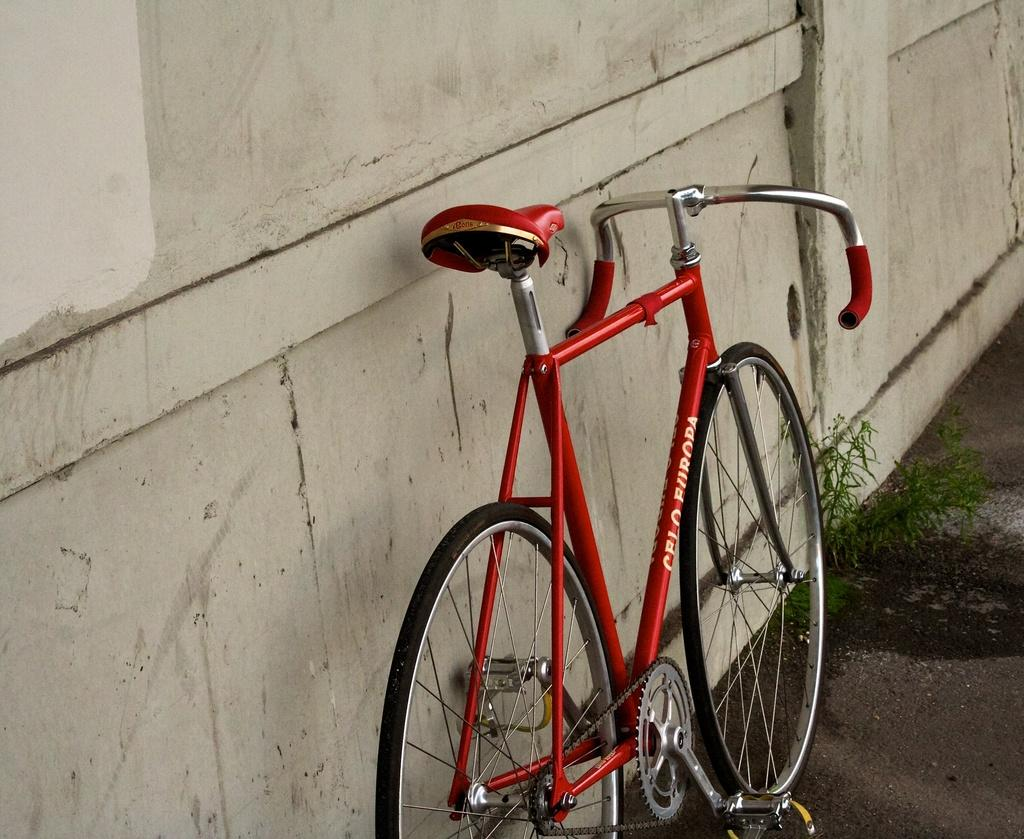What is the main object in the image? There is a bicycle in the image. Where is the bicycle located? The bicycle is on the land. What else can be seen on the land in the image? There are plants on the land. What is visible in the background of the image? There is a wall in the background of the image. What type of fowl can be seen walking on the sand in the image? There is no fowl or sand present in the image; it features a bicycle on the land with plants and a wall in the background. 